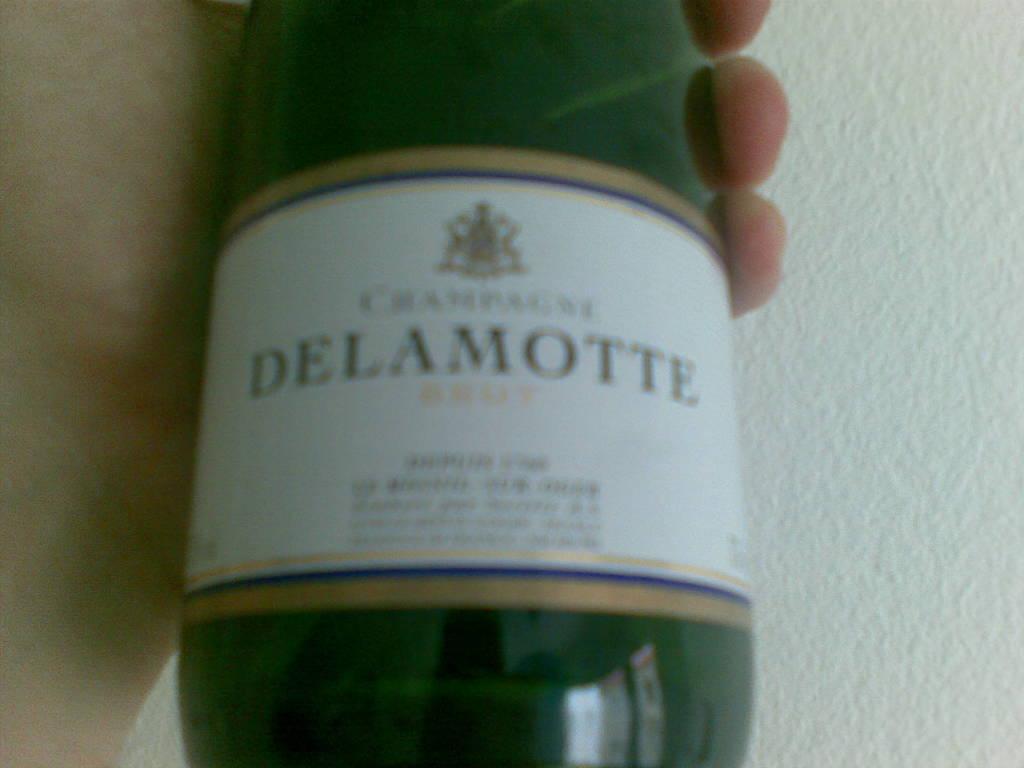Is this delamotte?
Your answer should be very brief. Yes. What kind of alcohol is this?
Your response must be concise. Delamotte. 